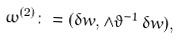<formula> <loc_0><loc_0><loc_500><loc_500>\omega ^ { ( 2 ) } \colon = ( \delta w , \wedge \vartheta ^ { - 1 } \, \delta w ) ,</formula> 